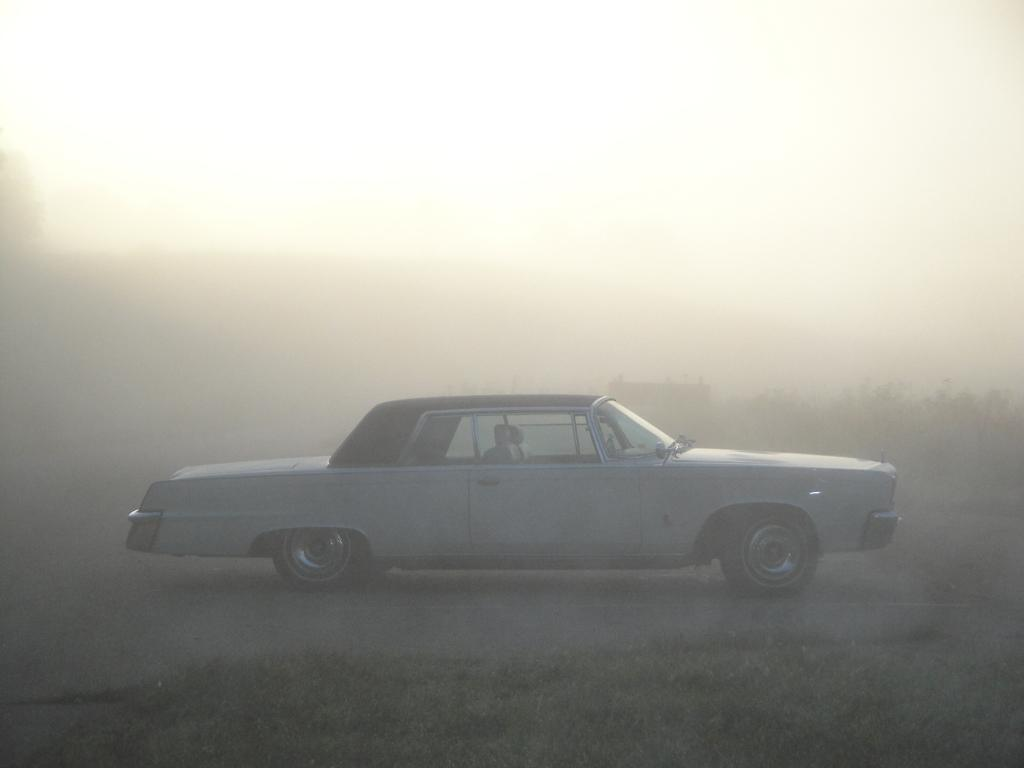What is the main subject of the image? There is a car in the image. Can you describe the overall appearance of the image? The image is completely foggy. How many pigs are sitting in the passenger seat of the car in the image? There are no pigs present in the image; it only features a car in a foggy setting. 